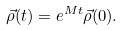<formula> <loc_0><loc_0><loc_500><loc_500>\vec { \rho } ( t ) = e ^ { M t } \vec { \rho } ( 0 ) .</formula> 